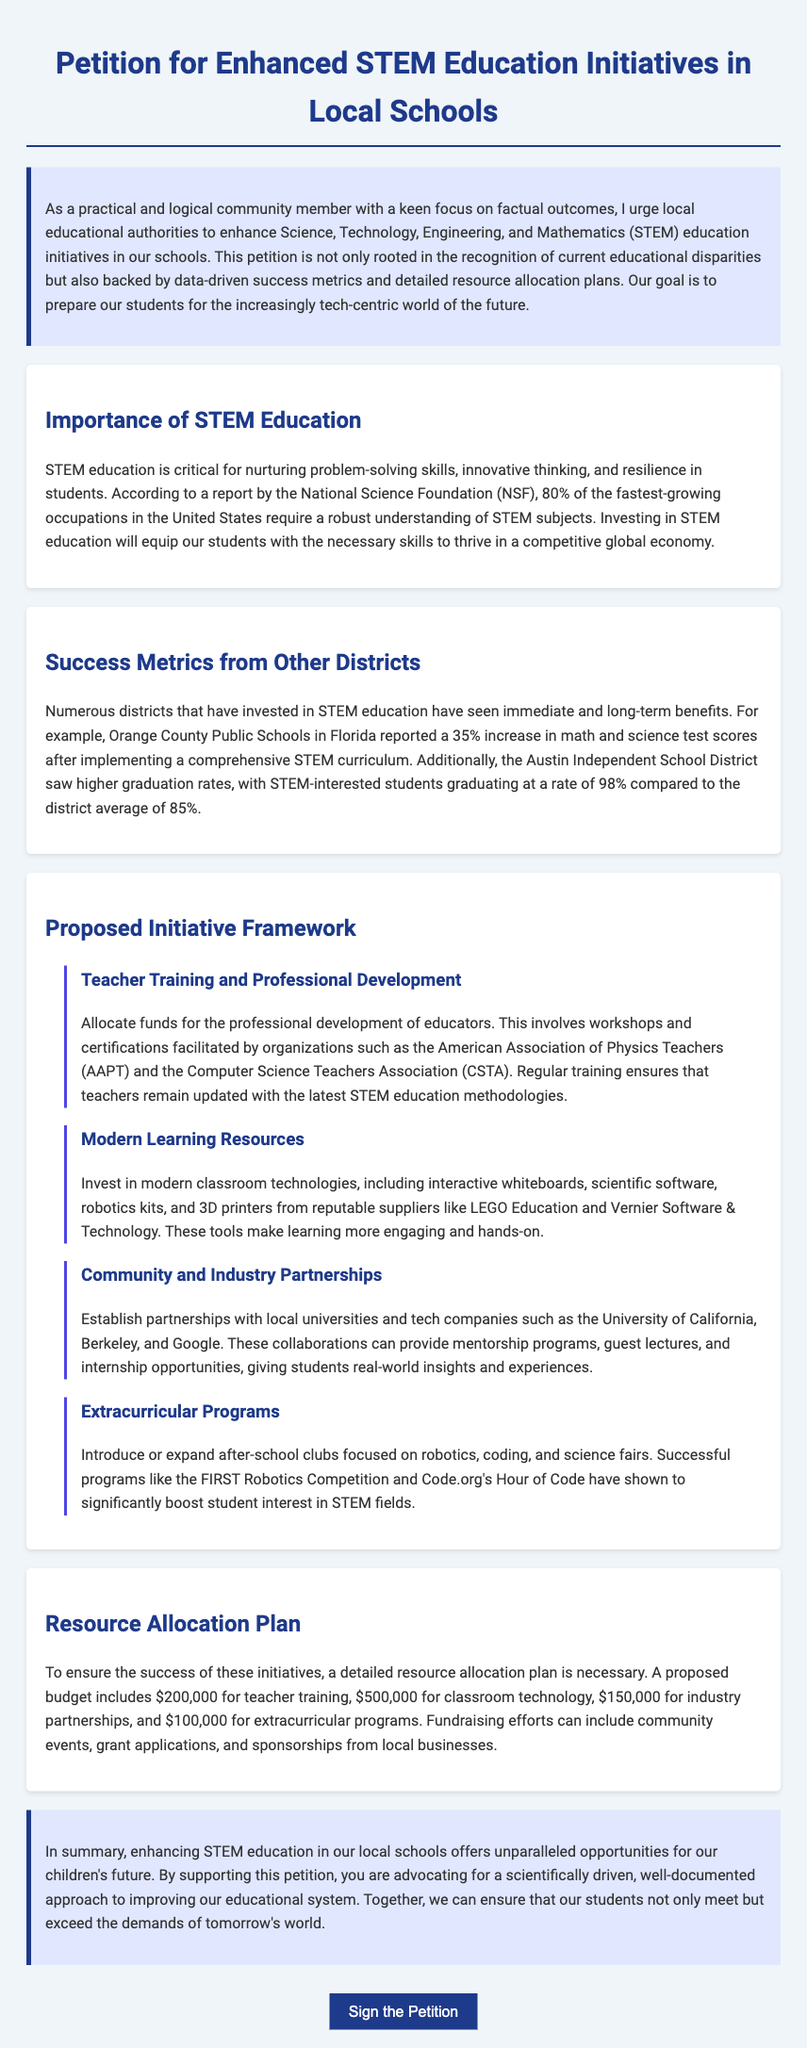What is the title of the petition? The title of the petition is mentioned at the top of the document.
Answer: Petition for Enhanced STEM Education Initiatives in Local Schools What percentage increase in math and science test scores did Orange County Public Schools report after implementing a comprehensive STEM curriculum? The specific percentage increase is highlighted in the success metrics section of the document.
Answer: 35% What is the proposed budget for classroom technology? The proposed budget amounts are listed in the resource allocation plan section.
Answer: $500,000 Which organization is mentioned for teacher training and professional development? The organization is specified in the proposed initiative framework section.
Answer: American Association of Physics Teachers What is the graduation rate for STEM-interested students in the Austin Independent School District? This information is presented in the success metrics section of the document.
Answer: 98% How much funding is suggested for extracurricular programs? The proposed funding amount is outlined in the resource allocation plan.
Answer: $100,000 What type of partners does the document suggest establishing for mentorship programs? The partners are identified in the community and industry partnerships subsection.
Answer: Local universities and tech companies What is one of the successful extracurricular programs mentioned? The successful program is noted in the extracurricular programs subsection.
Answer: FIRST Robotics Competition What is stated as a critical requirement for STEM education in the document? This is discussed in the importance of STEM education section.
Answer: Nurturing problem-solving skills 